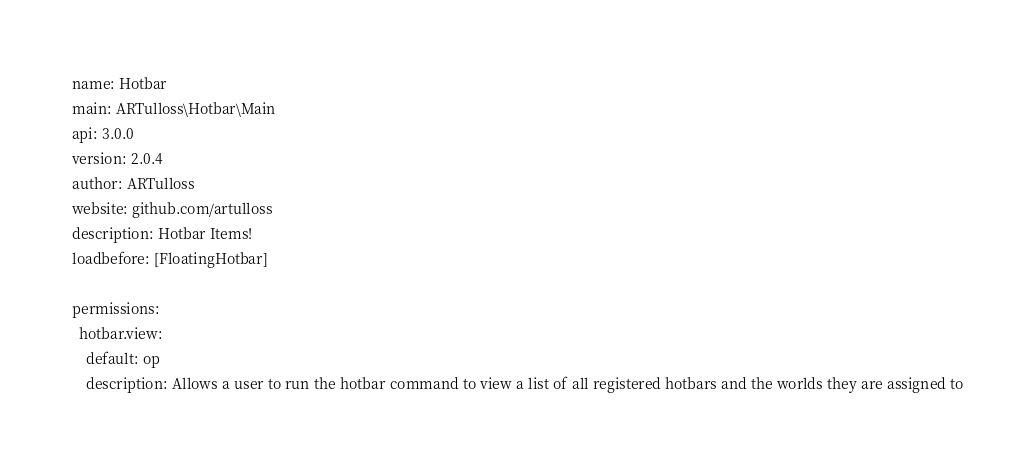Convert code to text. <code><loc_0><loc_0><loc_500><loc_500><_YAML_>name: Hotbar
main: ARTulloss\Hotbar\Main
api: 3.0.0
version: 2.0.4
author: ARTulloss
website: github.com/artulloss
description: Hotbar Items!
loadbefore: [FloatingHotbar]

permissions:
  hotbar.view:
    default: op
    description: Allows a user to run the hotbar command to view a list of all registered hotbars and the worlds they are assigned to
</code> 